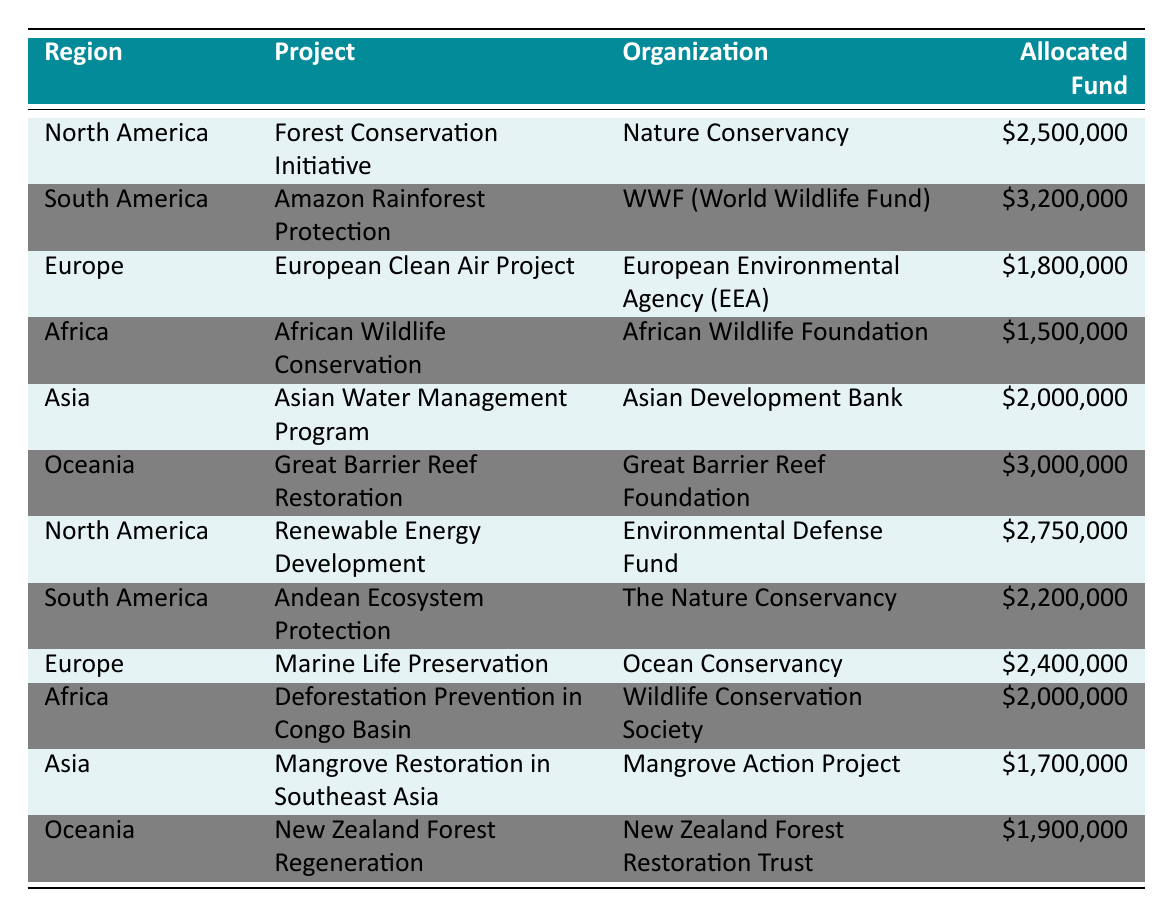What is the total allocated fund for projects in North America? The allocated funds for projects in North America are $2,500,000 for the Forest Conservation Initiative and $2,750,000 for Renewable Energy Development. Adding these amounts gives $2,500,000 + $2,750,000 = $5,250,000.
Answer: 5,250,000 Which organization is funding the Amazon Rainforest Protection project? The row for the Amazon Rainforest Protection project states that the organization involved is the WWF (World Wildlife Fund).
Answer: WWF (World Wildlife Fund) Is the allocated fund for the Great Barrier Reef Restoration higher than the total fund for the Mangrove Restoration in Southeast Asia? The allocated fund for the Great Barrier Reef Restoration is $3,000,000, while the Mangrove Restoration in Southeast Asia has an allocated fund of $1,700,000. Since $3,000,000 is greater than $1,700,000, the statement is true.
Answer: Yes What is the average allocated fund for projects in Africa? The projects in Africa are the African Wildlife Conservation with $1,500,000 and Deforestation Prevention in Congo Basin with $2,000,000. The total for these two is $1,500,000 + $2,000,000 = $3,500,000. The average is $3,500,000 divided by 2, which equals $1,750,000.
Answer: 1,750,000 Which region has the highest allocated fund for its projects? The South America region has the Amazon Rainforest Protection project at $3,200,000, the highest amount compared to other regions' projects.
Answer: South America 